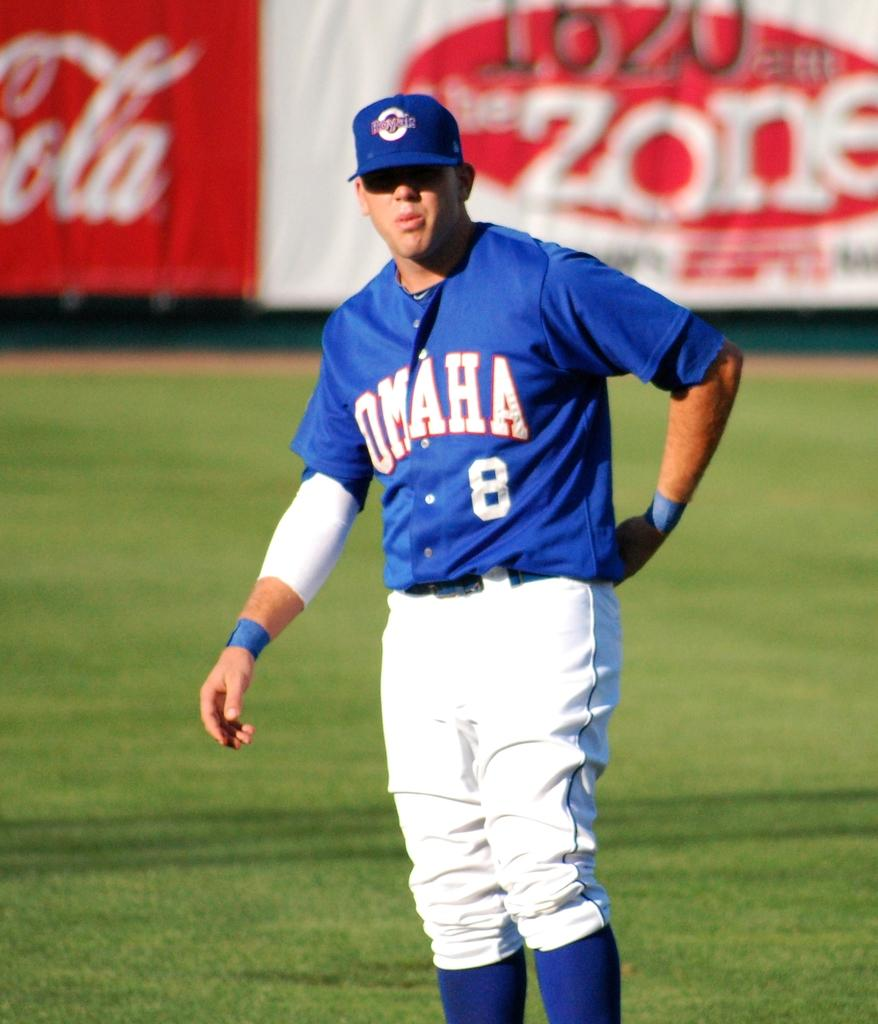<image>
Render a clear and concise summary of the photo. Player number 8 for Omaha adjusts his pants. 